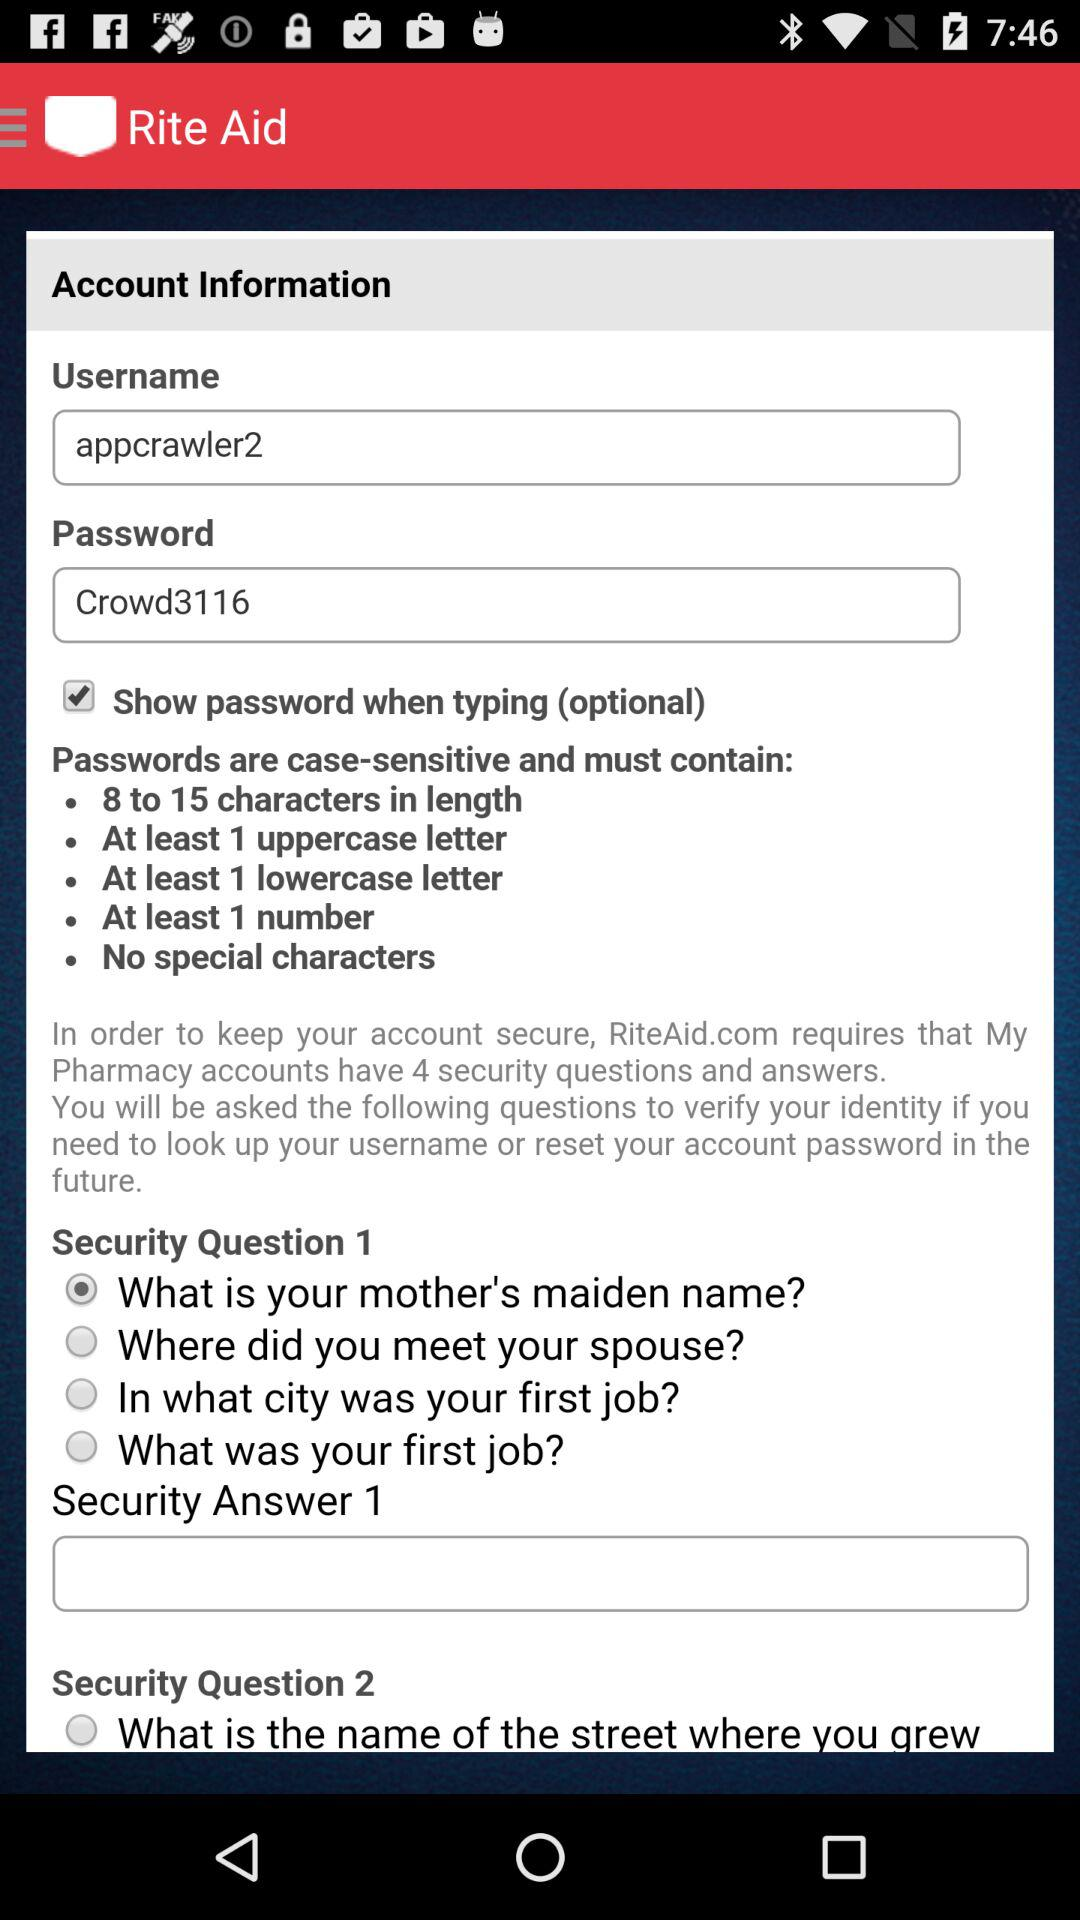What is the number of characters required for a password? The number of characters required for a password is 8 to 15. 